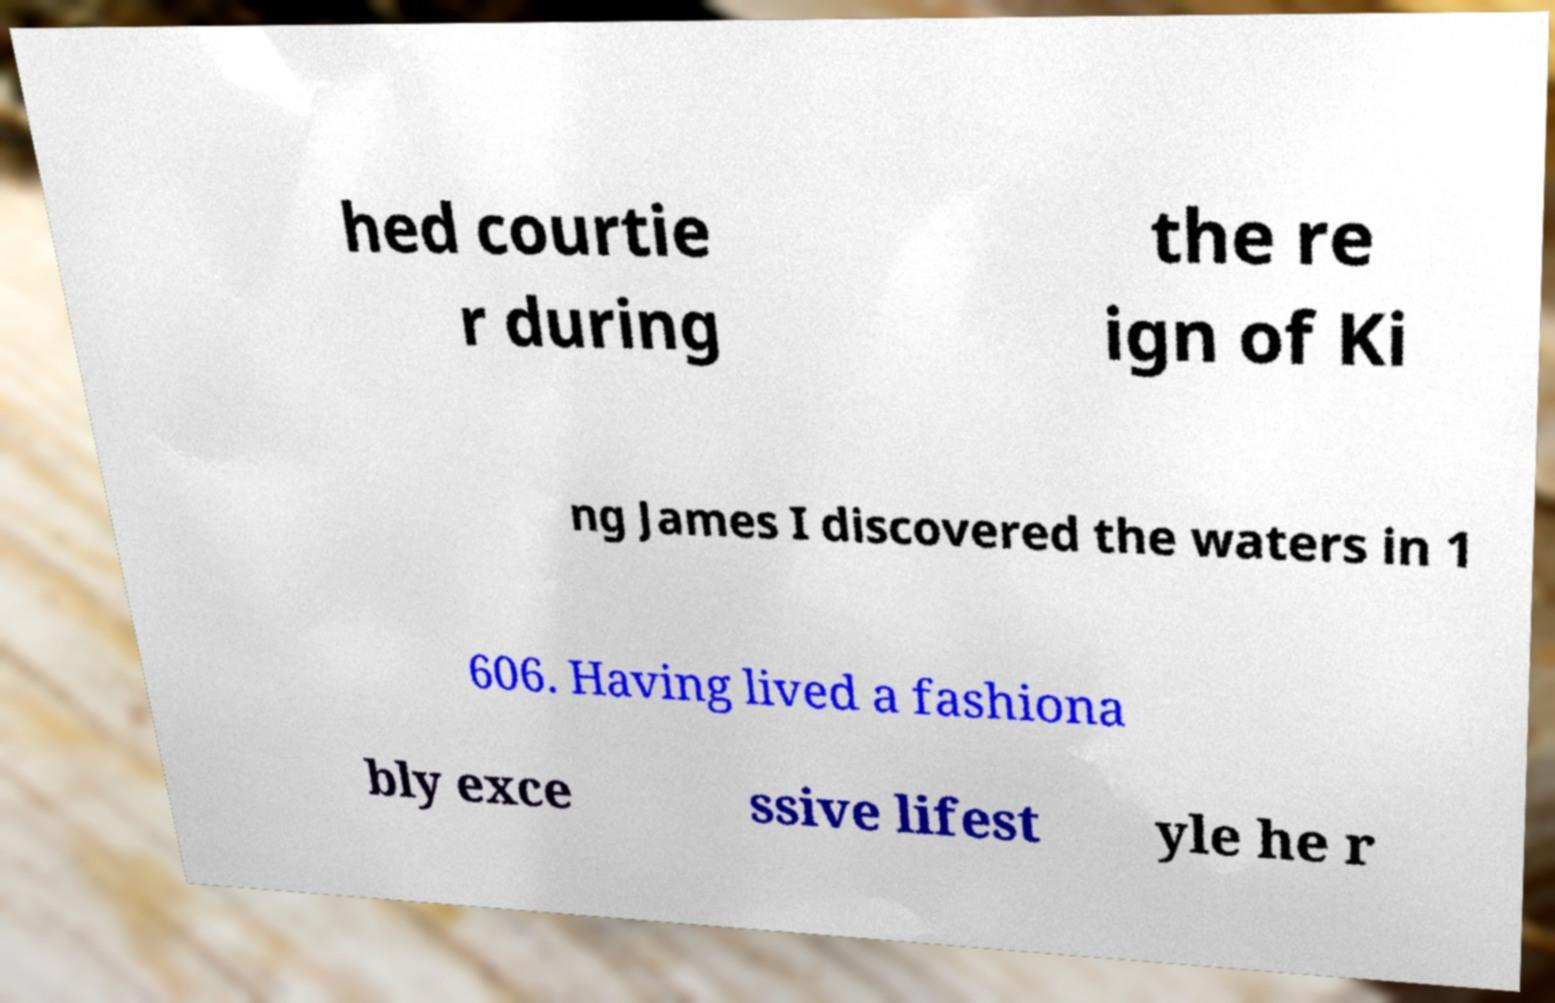Please identify and transcribe the text found in this image. hed courtie r during the re ign of Ki ng James I discovered the waters in 1 606. Having lived a fashiona bly exce ssive lifest yle he r 